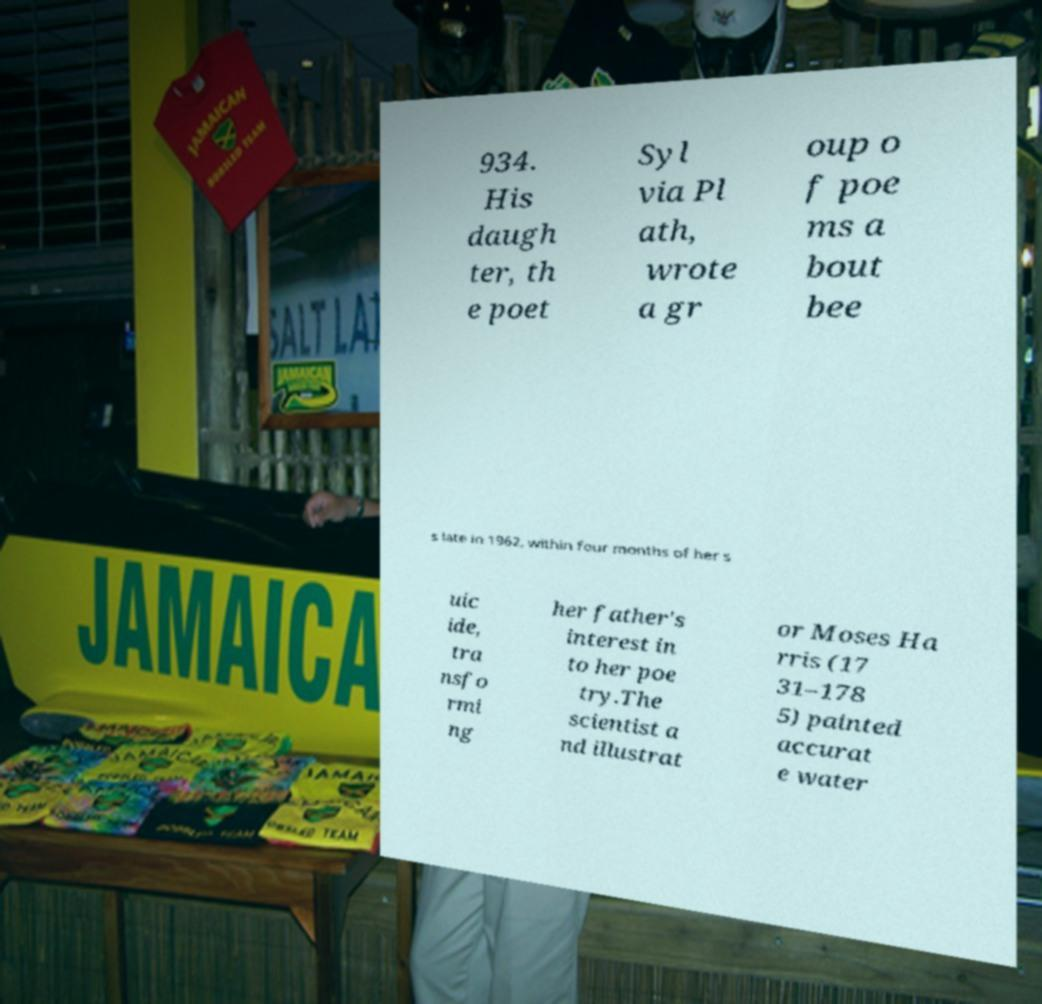Could you extract and type out the text from this image? 934. His daugh ter, th e poet Syl via Pl ath, wrote a gr oup o f poe ms a bout bee s late in 1962, within four months of her s uic ide, tra nsfo rmi ng her father's interest in to her poe try.The scientist a nd illustrat or Moses Ha rris (17 31–178 5) painted accurat e water 